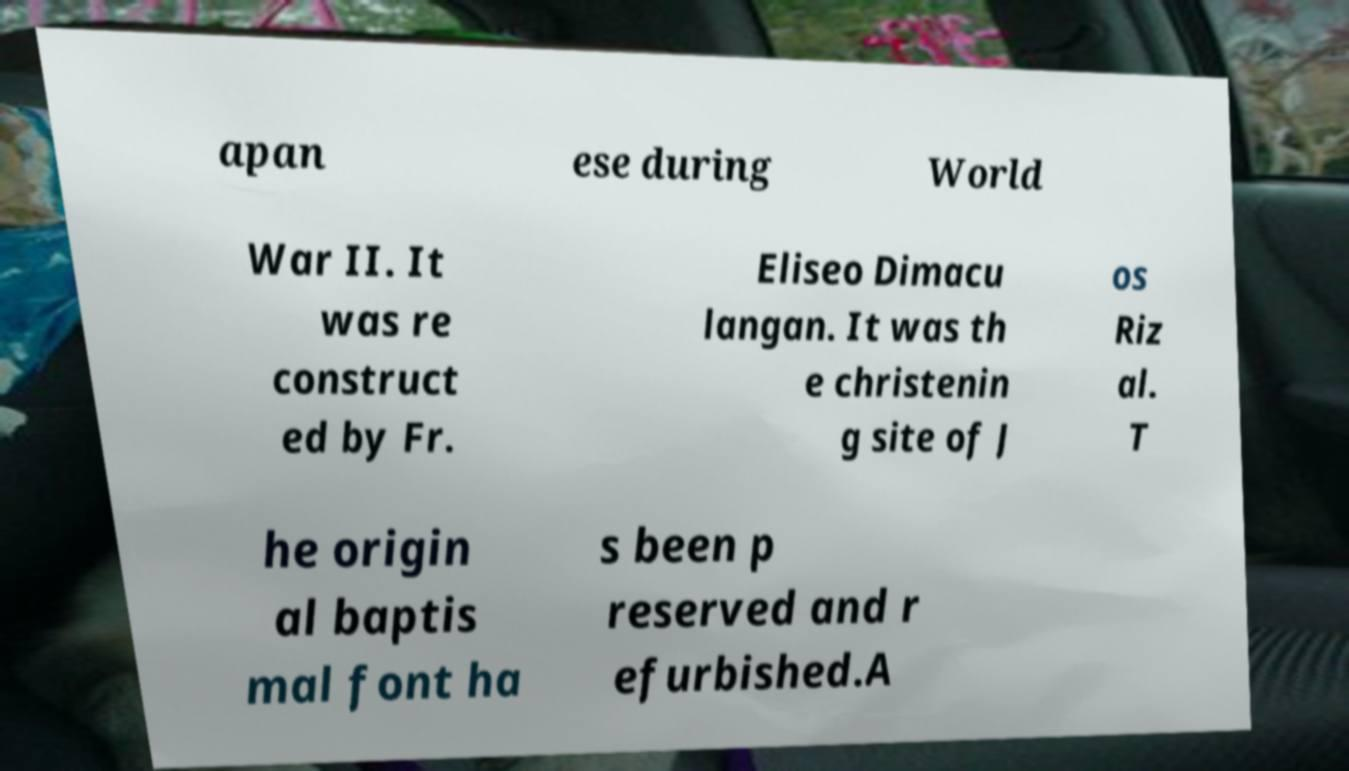Could you assist in decoding the text presented in this image and type it out clearly? apan ese during World War II. It was re construct ed by Fr. Eliseo Dimacu langan. It was th e christenin g site of J os Riz al. T he origin al baptis mal font ha s been p reserved and r efurbished.A 